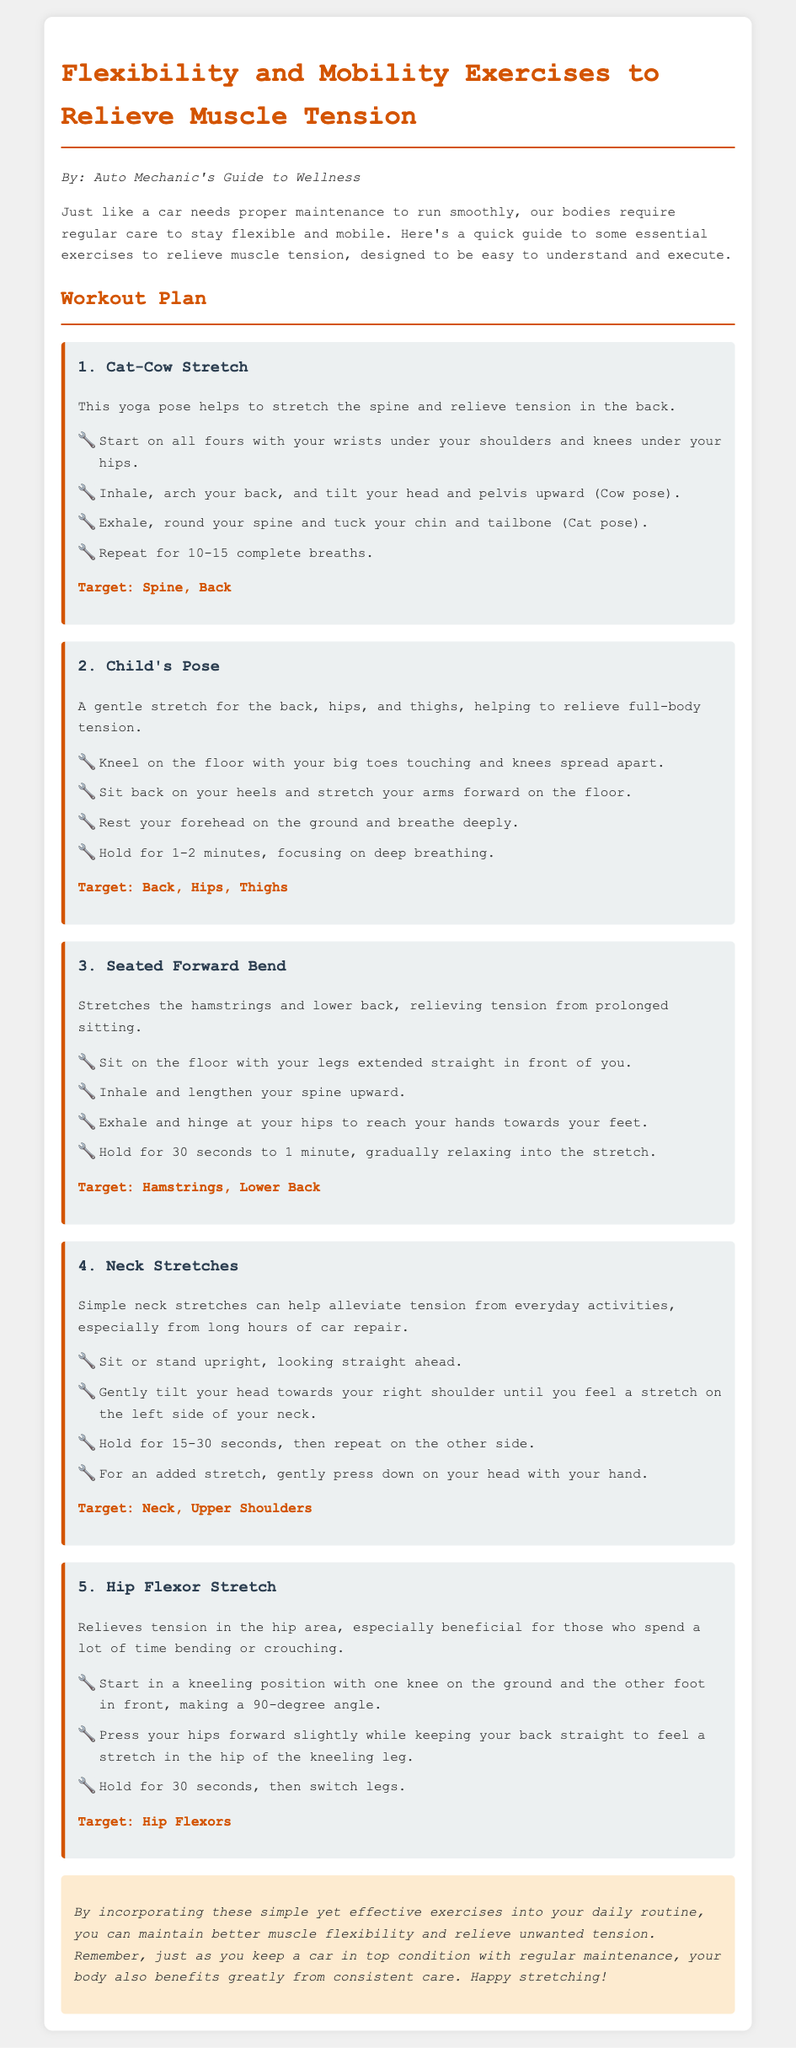What is the title of the document? The title is clearly listed at the top of the rendered document.
Answer: Flexibility and Mobility Exercises to Relieve Muscle Tension How many exercises are detailed in the workout plan? The number of exercises is indicated by the headings within the document.
Answer: 5 What is the target area for the Cat-Cow Stretch? The target area is listed immediately below the description of the exercise.
Answer: Spine, Back How long should you hold the Child's Pose? The recommended duration for holding the pose is mentioned in the steps for that exercise.
Answer: 1-2 minutes What equipment is needed for these exercises? The document does not mention any equipment, indicating they can be done without tools.
Answer: None Which exercise targets the Hip Flexors? The specific exercise is mentioned by name in the document.
Answer: Hip Flexor Stretch What is the purpose of the Neck Stretches? The purpose is described in the context of alleviating tension from specific activities.
Answer: Alleviate tension from everyday activities How many complete breaths should be done in the Cat-Cow Stretch? The number of breaths is stated in the instructions for that exercise.
Answer: 10-15 complete breaths 